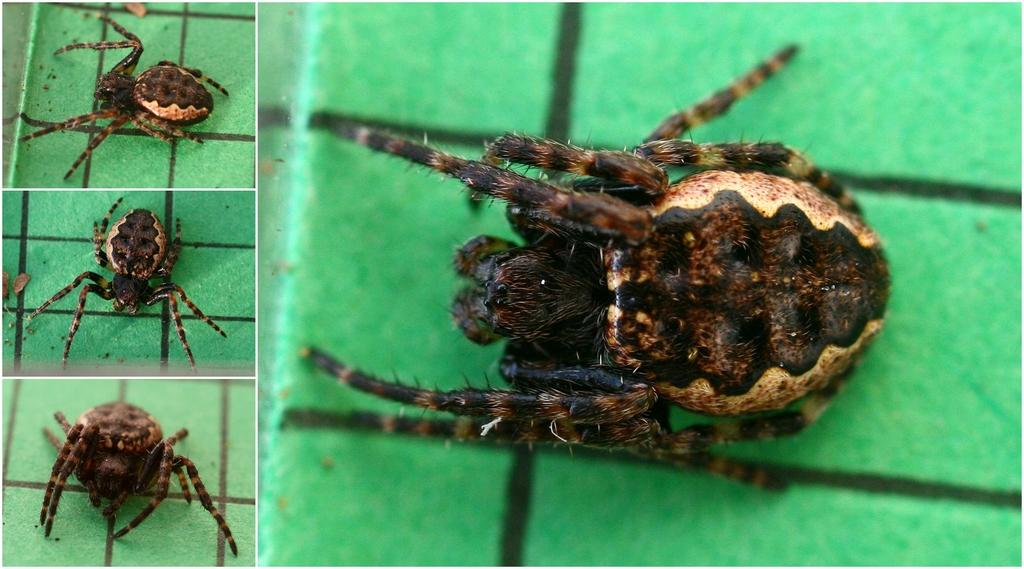What is the main subject of the image? The main subject of the image is a collage of a spider. Can you describe the collage in more detail? Unfortunately, the facts provided do not give any additional details about the collage. What type of chin is visible in the image? There is no chin present in the image, as it features a collage of a spider. How many brothers are depicted in the image? There are no people or figures in the image, so there are no brothers depicted. 